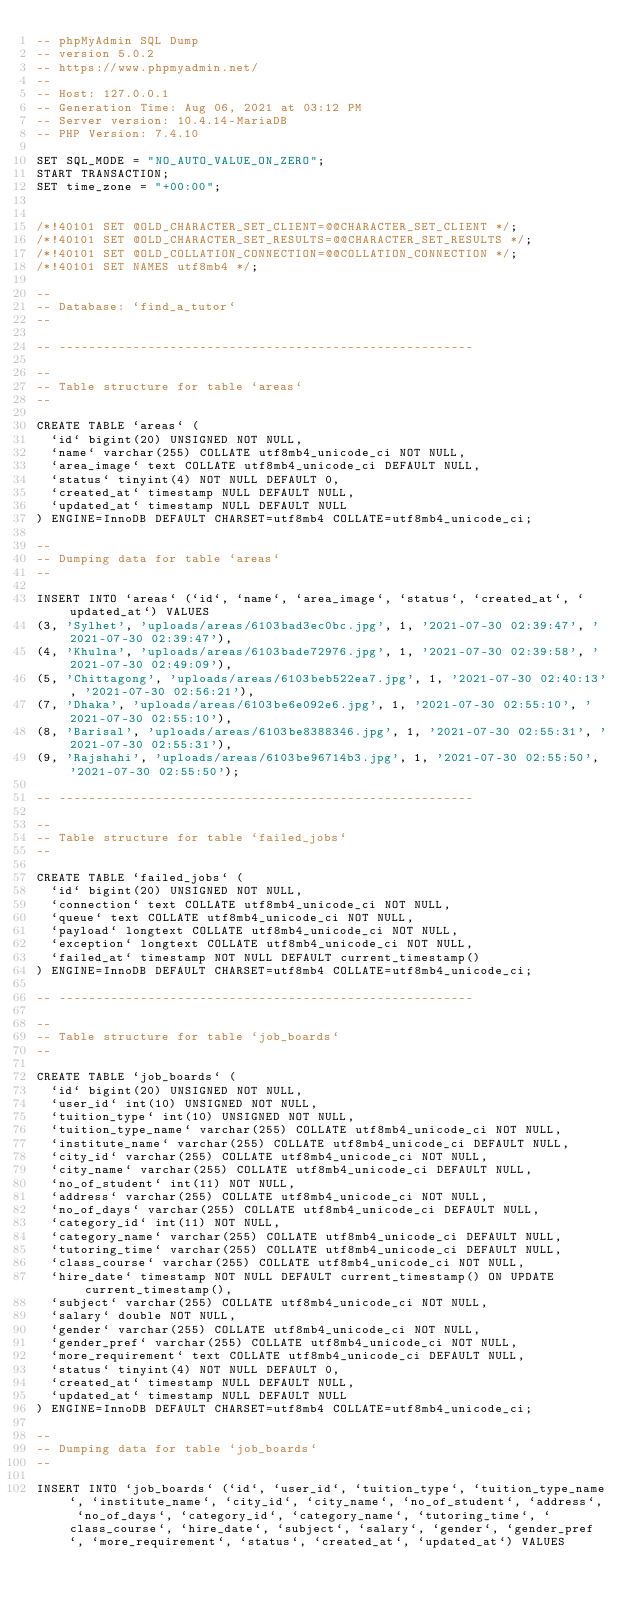<code> <loc_0><loc_0><loc_500><loc_500><_SQL_>-- phpMyAdmin SQL Dump
-- version 5.0.2
-- https://www.phpmyadmin.net/
--
-- Host: 127.0.0.1
-- Generation Time: Aug 06, 2021 at 03:12 PM
-- Server version: 10.4.14-MariaDB
-- PHP Version: 7.4.10

SET SQL_MODE = "NO_AUTO_VALUE_ON_ZERO";
START TRANSACTION;
SET time_zone = "+00:00";


/*!40101 SET @OLD_CHARACTER_SET_CLIENT=@@CHARACTER_SET_CLIENT */;
/*!40101 SET @OLD_CHARACTER_SET_RESULTS=@@CHARACTER_SET_RESULTS */;
/*!40101 SET @OLD_COLLATION_CONNECTION=@@COLLATION_CONNECTION */;
/*!40101 SET NAMES utf8mb4 */;

--
-- Database: `find_a_tutor`
--

-- --------------------------------------------------------

--
-- Table structure for table `areas`
--

CREATE TABLE `areas` (
  `id` bigint(20) UNSIGNED NOT NULL,
  `name` varchar(255) COLLATE utf8mb4_unicode_ci NOT NULL,
  `area_image` text COLLATE utf8mb4_unicode_ci DEFAULT NULL,
  `status` tinyint(4) NOT NULL DEFAULT 0,
  `created_at` timestamp NULL DEFAULT NULL,
  `updated_at` timestamp NULL DEFAULT NULL
) ENGINE=InnoDB DEFAULT CHARSET=utf8mb4 COLLATE=utf8mb4_unicode_ci;

--
-- Dumping data for table `areas`
--

INSERT INTO `areas` (`id`, `name`, `area_image`, `status`, `created_at`, `updated_at`) VALUES
(3, 'Sylhet', 'uploads/areas/6103bad3ec0bc.jpg', 1, '2021-07-30 02:39:47', '2021-07-30 02:39:47'),
(4, 'Khulna', 'uploads/areas/6103bade72976.jpg', 1, '2021-07-30 02:39:58', '2021-07-30 02:49:09'),
(5, 'Chittagong', 'uploads/areas/6103beb522ea7.jpg', 1, '2021-07-30 02:40:13', '2021-07-30 02:56:21'),
(7, 'Dhaka', 'uploads/areas/6103be6e092e6.jpg', 1, '2021-07-30 02:55:10', '2021-07-30 02:55:10'),
(8, 'Barisal', 'uploads/areas/6103be8388346.jpg', 1, '2021-07-30 02:55:31', '2021-07-30 02:55:31'),
(9, 'Rajshahi', 'uploads/areas/6103be96714b3.jpg', 1, '2021-07-30 02:55:50', '2021-07-30 02:55:50');

-- --------------------------------------------------------

--
-- Table structure for table `failed_jobs`
--

CREATE TABLE `failed_jobs` (
  `id` bigint(20) UNSIGNED NOT NULL,
  `connection` text COLLATE utf8mb4_unicode_ci NOT NULL,
  `queue` text COLLATE utf8mb4_unicode_ci NOT NULL,
  `payload` longtext COLLATE utf8mb4_unicode_ci NOT NULL,
  `exception` longtext COLLATE utf8mb4_unicode_ci NOT NULL,
  `failed_at` timestamp NOT NULL DEFAULT current_timestamp()
) ENGINE=InnoDB DEFAULT CHARSET=utf8mb4 COLLATE=utf8mb4_unicode_ci;

-- --------------------------------------------------------

--
-- Table structure for table `job_boards`
--

CREATE TABLE `job_boards` (
  `id` bigint(20) UNSIGNED NOT NULL,
  `user_id` int(10) UNSIGNED NOT NULL,
  `tuition_type` int(10) UNSIGNED NOT NULL,
  `tuition_type_name` varchar(255) COLLATE utf8mb4_unicode_ci NOT NULL,
  `institute_name` varchar(255) COLLATE utf8mb4_unicode_ci DEFAULT NULL,
  `city_id` varchar(255) COLLATE utf8mb4_unicode_ci NOT NULL,
  `city_name` varchar(255) COLLATE utf8mb4_unicode_ci DEFAULT NULL,
  `no_of_student` int(11) NOT NULL,
  `address` varchar(255) COLLATE utf8mb4_unicode_ci NOT NULL,
  `no_of_days` varchar(255) COLLATE utf8mb4_unicode_ci DEFAULT NULL,
  `category_id` int(11) NOT NULL,
  `category_name` varchar(255) COLLATE utf8mb4_unicode_ci DEFAULT NULL,
  `tutoring_time` varchar(255) COLLATE utf8mb4_unicode_ci DEFAULT NULL,
  `class_course` varchar(255) COLLATE utf8mb4_unicode_ci NOT NULL,
  `hire_date` timestamp NOT NULL DEFAULT current_timestamp() ON UPDATE current_timestamp(),
  `subject` varchar(255) COLLATE utf8mb4_unicode_ci NOT NULL,
  `salary` double NOT NULL,
  `gender` varchar(255) COLLATE utf8mb4_unicode_ci NOT NULL,
  `gender_pref` varchar(255) COLLATE utf8mb4_unicode_ci NOT NULL,
  `more_requirement` text COLLATE utf8mb4_unicode_ci DEFAULT NULL,
  `status` tinyint(4) NOT NULL DEFAULT 0,
  `created_at` timestamp NULL DEFAULT NULL,
  `updated_at` timestamp NULL DEFAULT NULL
) ENGINE=InnoDB DEFAULT CHARSET=utf8mb4 COLLATE=utf8mb4_unicode_ci;

--
-- Dumping data for table `job_boards`
--

INSERT INTO `job_boards` (`id`, `user_id`, `tuition_type`, `tuition_type_name`, `institute_name`, `city_id`, `city_name`, `no_of_student`, `address`, `no_of_days`, `category_id`, `category_name`, `tutoring_time`, `class_course`, `hire_date`, `subject`, `salary`, `gender`, `gender_pref`, `more_requirement`, `status`, `created_at`, `updated_at`) VALUES</code> 